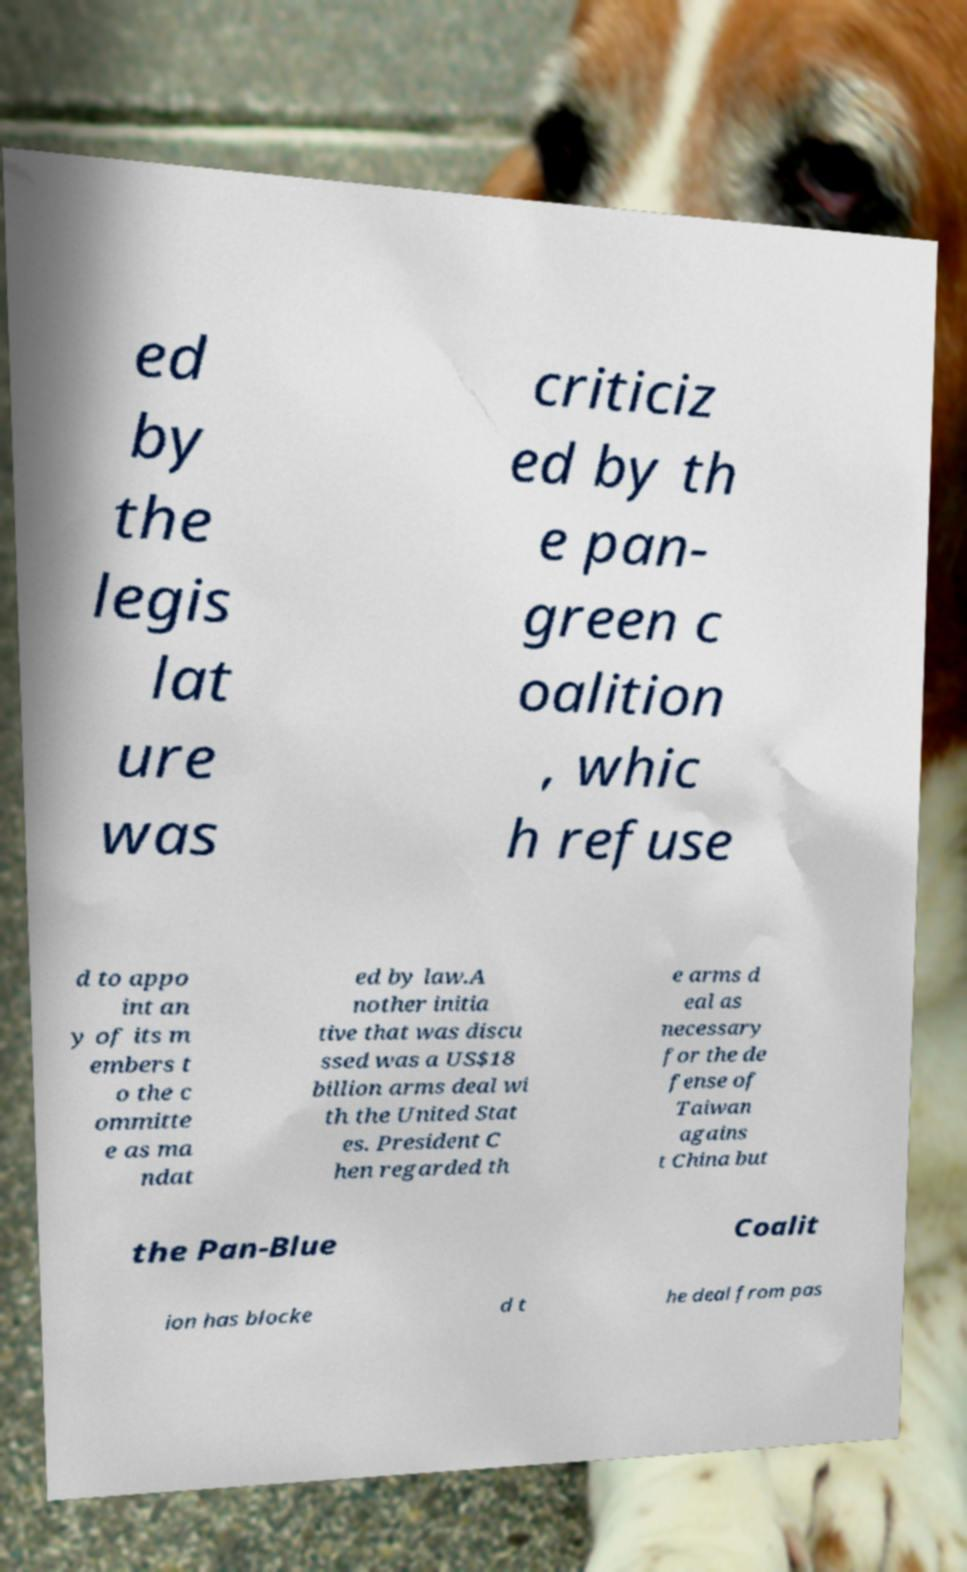Can you read and provide the text displayed in the image?This photo seems to have some interesting text. Can you extract and type it out for me? ed by the legis lat ure was criticiz ed by th e pan- green c oalition , whic h refuse d to appo int an y of its m embers t o the c ommitte e as ma ndat ed by law.A nother initia tive that was discu ssed was a US$18 billion arms deal wi th the United Stat es. President C hen regarded th e arms d eal as necessary for the de fense of Taiwan agains t China but the Pan-Blue Coalit ion has blocke d t he deal from pas 